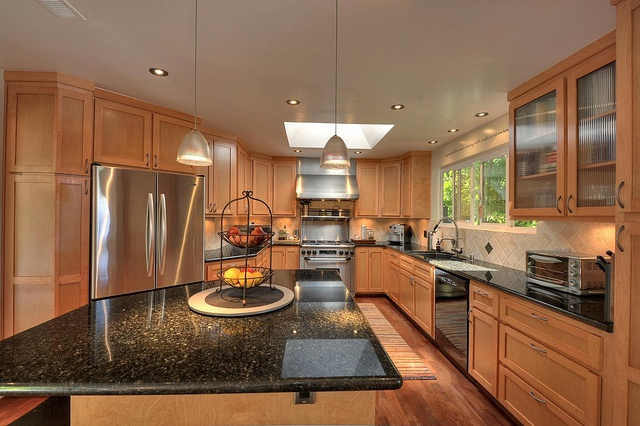Describe the objects in this image and their specific colors. I can see dining table in gray, black, and tan tones, refrigerator in gray, brown, and maroon tones, oven in gray, darkgray, maroon, and black tones, microwave in gray, maroon, and black tones, and orange in gray, orange, olive, and maroon tones in this image. 